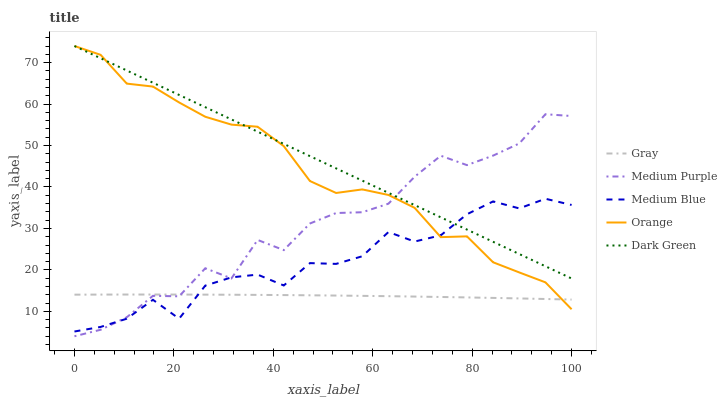Does Gray have the minimum area under the curve?
Answer yes or no. Yes. Does Dark Green have the maximum area under the curve?
Answer yes or no. Yes. Does Orange have the minimum area under the curve?
Answer yes or no. No. Does Orange have the maximum area under the curve?
Answer yes or no. No. Is Dark Green the smoothest?
Answer yes or no. Yes. Is Medium Purple the roughest?
Answer yes or no. Yes. Is Gray the smoothest?
Answer yes or no. No. Is Gray the roughest?
Answer yes or no. No. Does Medium Purple have the lowest value?
Answer yes or no. Yes. Does Gray have the lowest value?
Answer yes or no. No. Does Dark Green have the highest value?
Answer yes or no. Yes. Does Gray have the highest value?
Answer yes or no. No. Is Gray less than Dark Green?
Answer yes or no. Yes. Is Dark Green greater than Gray?
Answer yes or no. Yes. Does Gray intersect Medium Blue?
Answer yes or no. Yes. Is Gray less than Medium Blue?
Answer yes or no. No. Is Gray greater than Medium Blue?
Answer yes or no. No. Does Gray intersect Dark Green?
Answer yes or no. No. 